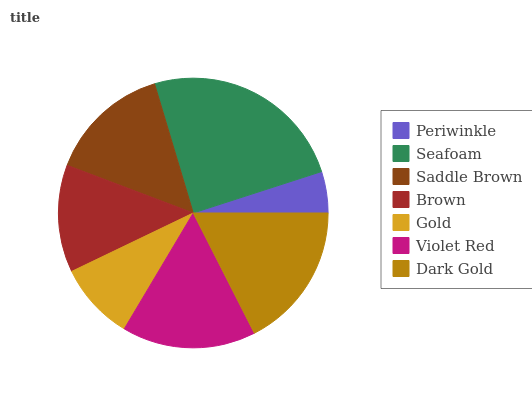Is Periwinkle the minimum?
Answer yes or no. Yes. Is Seafoam the maximum?
Answer yes or no. Yes. Is Saddle Brown the minimum?
Answer yes or no. No. Is Saddle Brown the maximum?
Answer yes or no. No. Is Seafoam greater than Saddle Brown?
Answer yes or no. Yes. Is Saddle Brown less than Seafoam?
Answer yes or no. Yes. Is Saddle Brown greater than Seafoam?
Answer yes or no. No. Is Seafoam less than Saddle Brown?
Answer yes or no. No. Is Saddle Brown the high median?
Answer yes or no. Yes. Is Saddle Brown the low median?
Answer yes or no. Yes. Is Seafoam the high median?
Answer yes or no. No. Is Dark Gold the low median?
Answer yes or no. No. 